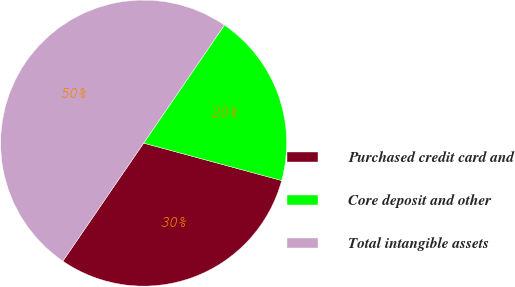Convert chart. <chart><loc_0><loc_0><loc_500><loc_500><pie_chart><fcel>Purchased credit card and<fcel>Core deposit and other<fcel>Total intangible assets<nl><fcel>30.34%<fcel>19.66%<fcel>50.0%<nl></chart> 